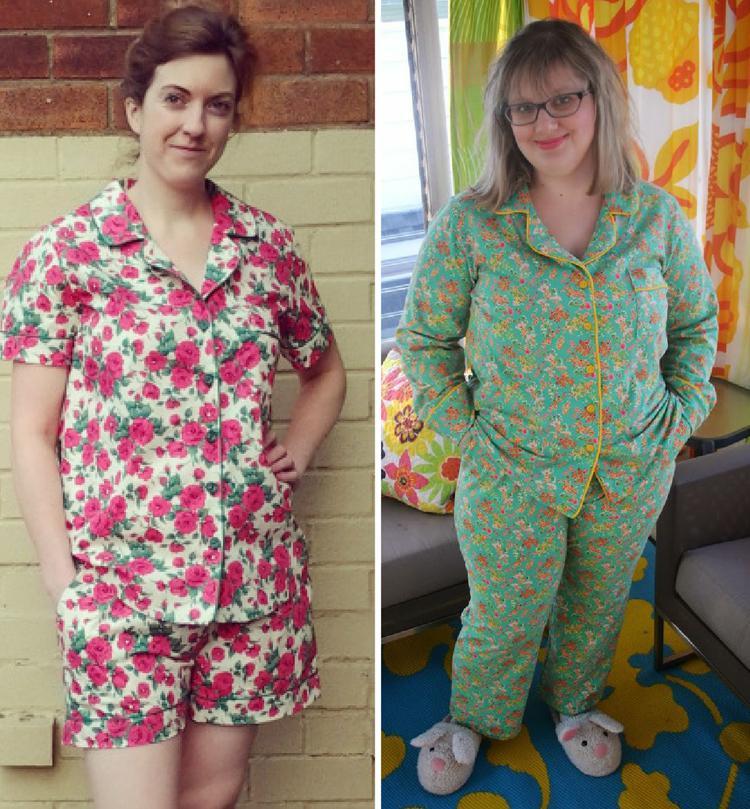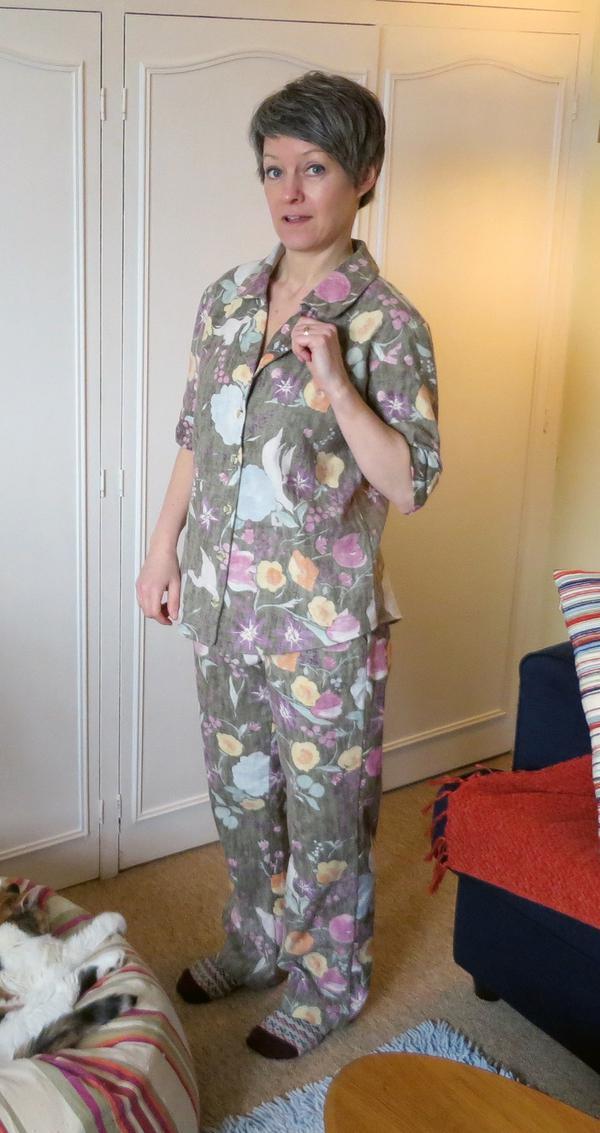The first image is the image on the left, the second image is the image on the right. Evaluate the accuracy of this statement regarding the images: "One image has two ladies with one of the ladies wearing shorts.". Is it true? Answer yes or no. Yes. 